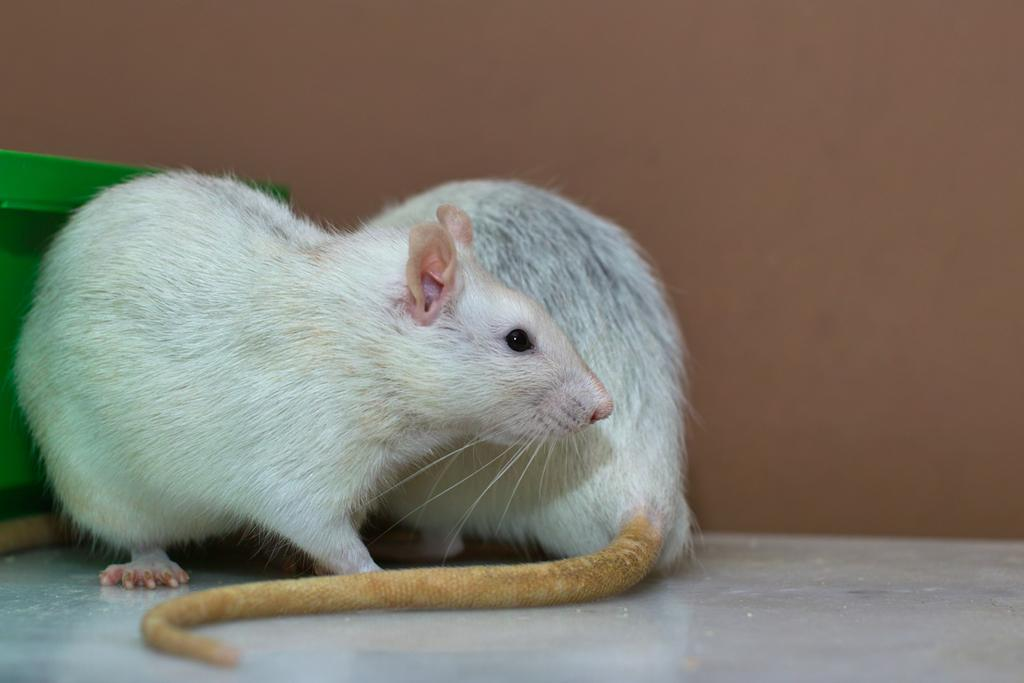What is the main object in the center of the image? There is a green object in the center of the image. What animals can be seen in the image? There are two white mice in the image. What is visible in the background of the image? There is a wall in the background of the image. How many drops of water can be seen falling from the ceiling in the image? There are no drops of water visible in the image. What question is the green object asking the mice in the image? The green object is not asking any questions in the image, as it is an inanimate object. 